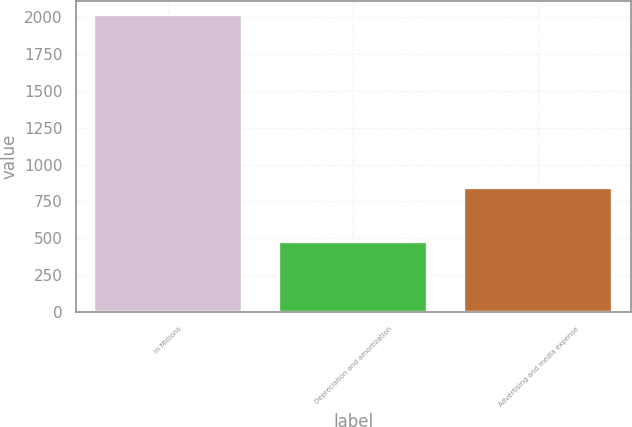Convert chart. <chart><loc_0><loc_0><loc_500><loc_500><bar_chart><fcel>In Millions<fcel>Depreciation and amortization<fcel>Advertising and media expense<nl><fcel>2011<fcel>472.6<fcel>843.7<nl></chart> 